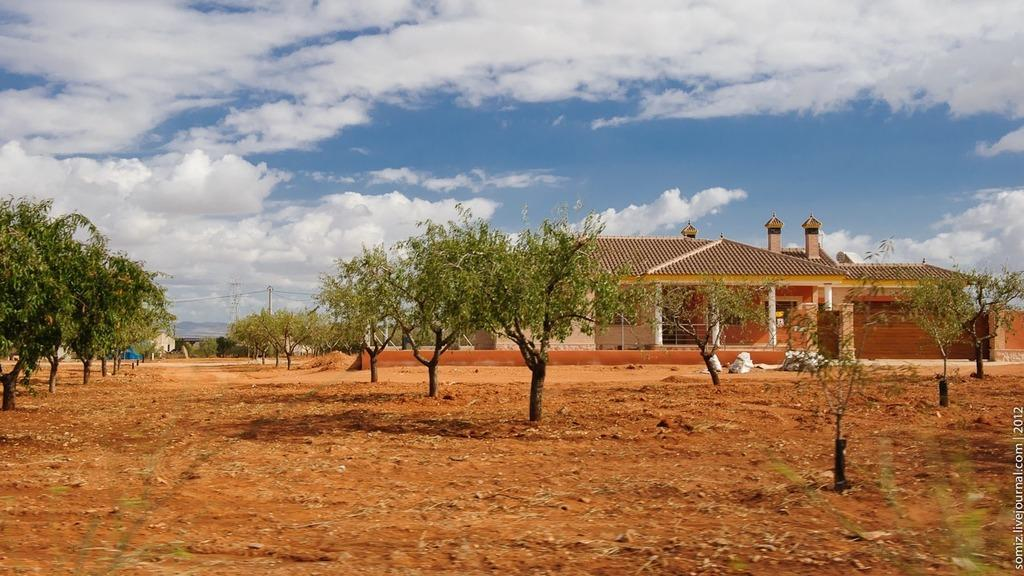What type of surface is visible in the image? There is ground visible in the image. What type of vegetation can be seen in the image? There are trees in the image. What type of structure is present in the image? There is a house in the image. What type of objects are present in the image that are used for support or attachment? There are poles in the image. What is visible in the background of the image? The sky is visible in the background of the image. What type of bag is hanging from the chin of the person in the image? There is no person present in the image, and therefore no chin or bag can be observed. 